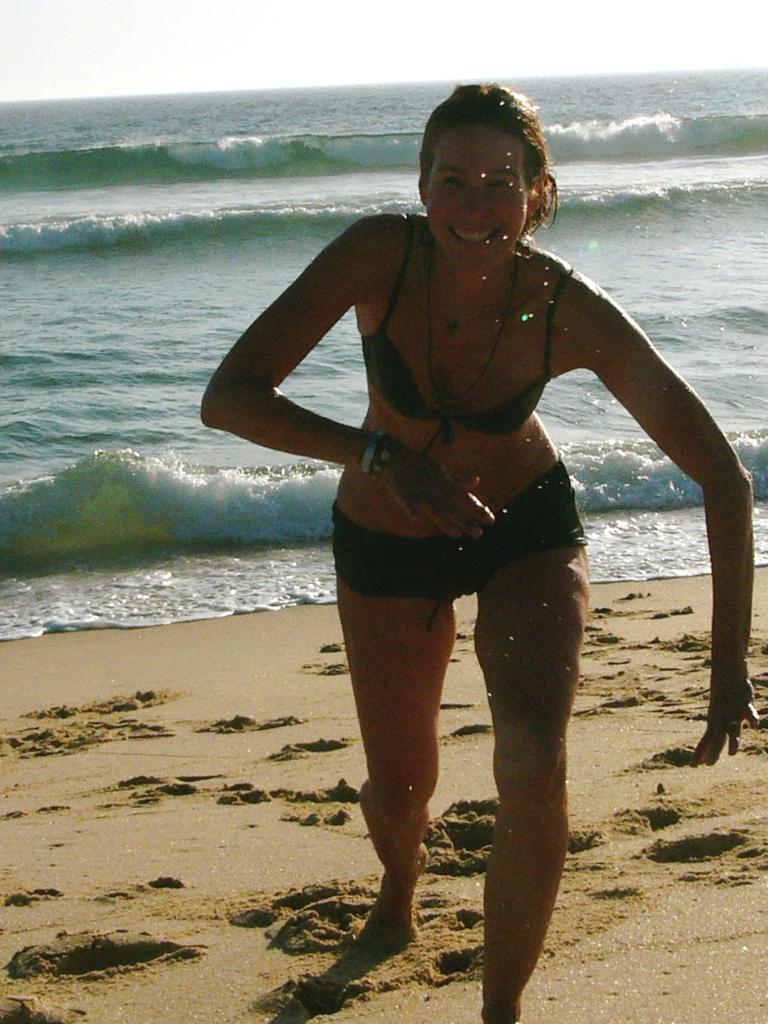Describe this image in one or two sentences. In this image there is a lady standing at the seashore on the beach. 